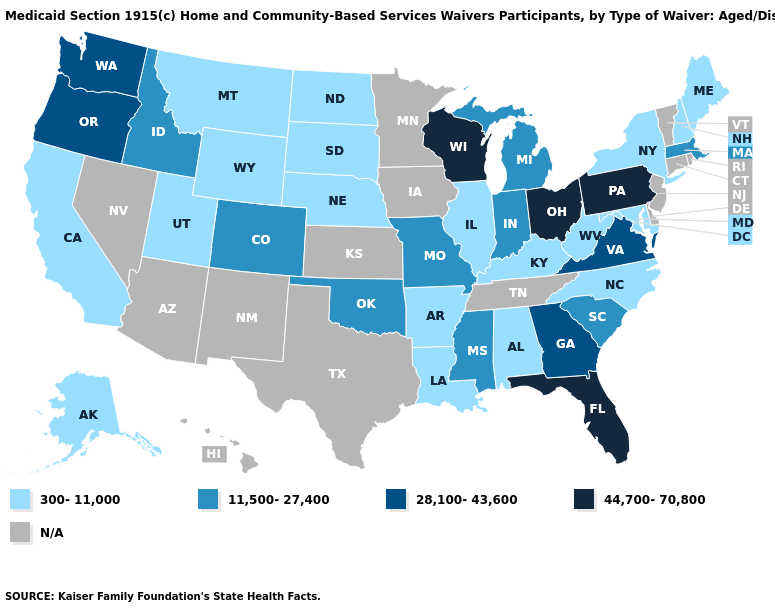What is the highest value in the Northeast ?
Be succinct. 44,700-70,800. What is the lowest value in the USA?
Short answer required. 300-11,000. How many symbols are there in the legend?
Concise answer only. 5. Does Ohio have the highest value in the USA?
Concise answer only. Yes. What is the highest value in states that border Virginia?
Short answer required. 300-11,000. Does Montana have the highest value in the USA?
Write a very short answer. No. Among the states that border Maryland , does West Virginia have the highest value?
Answer briefly. No. What is the highest value in the USA?
Quick response, please. 44,700-70,800. Name the states that have a value in the range 28,100-43,600?
Be succinct. Georgia, Oregon, Virginia, Washington. Does Ohio have the highest value in the USA?
Be succinct. Yes. Among the states that border Maryland , which have the highest value?
Quick response, please. Pennsylvania. Name the states that have a value in the range N/A?
Keep it brief. Arizona, Connecticut, Delaware, Hawaii, Iowa, Kansas, Minnesota, Nevada, New Jersey, New Mexico, Rhode Island, Tennessee, Texas, Vermont. What is the lowest value in the West?
Quick response, please. 300-11,000. 